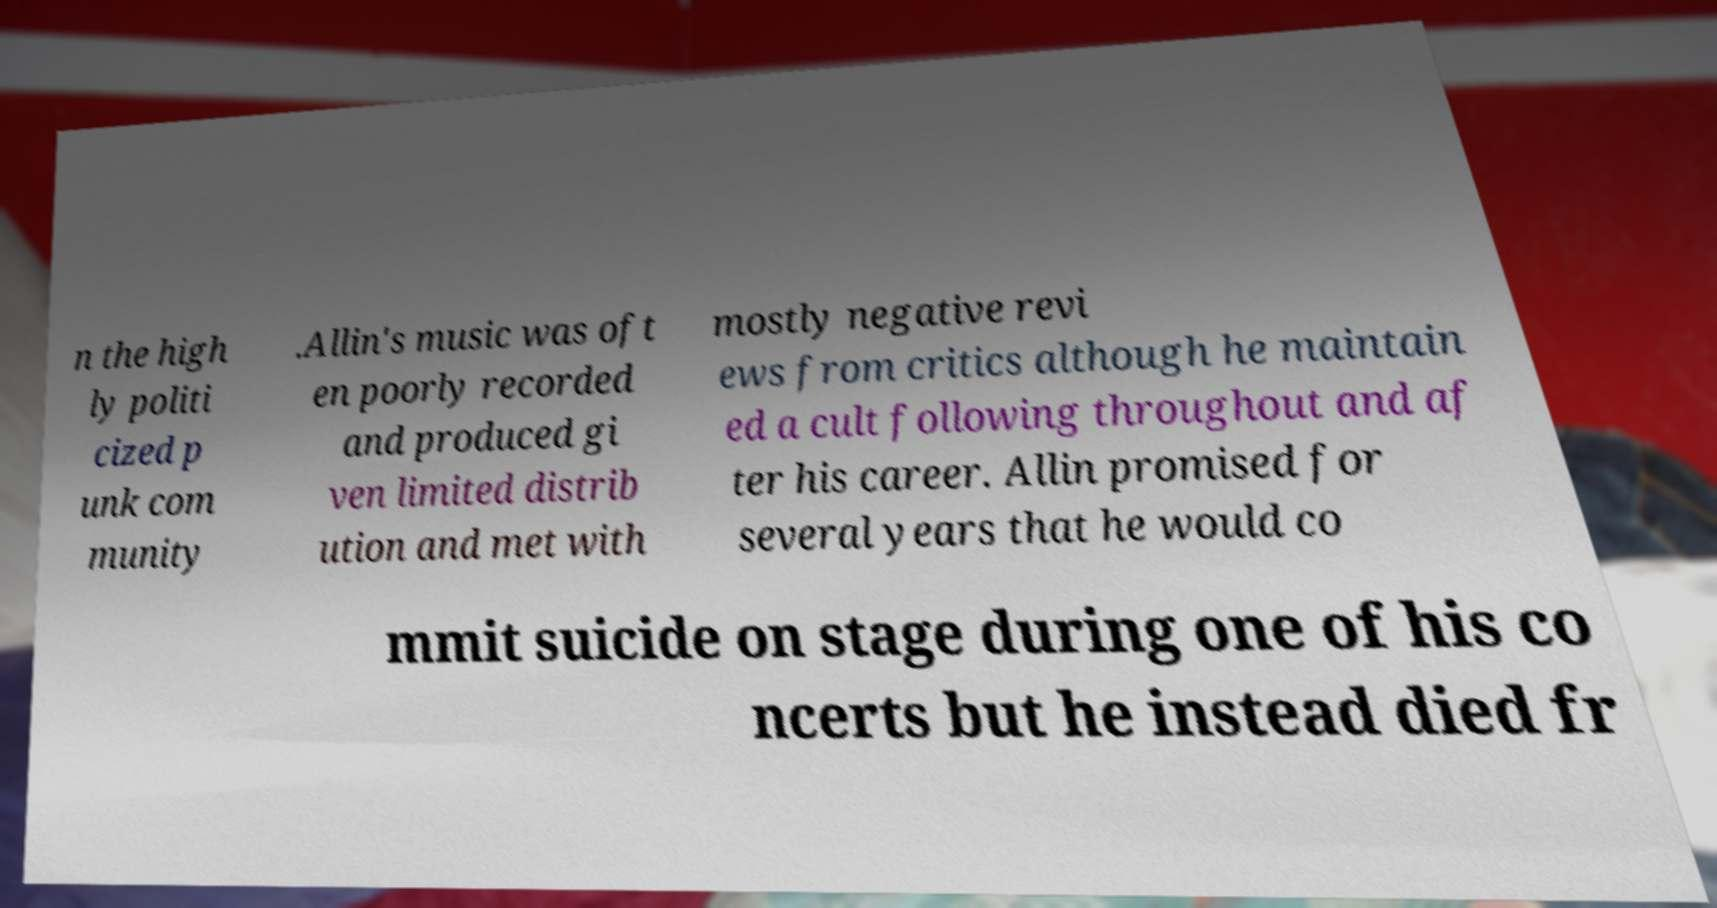Can you accurately transcribe the text from the provided image for me? n the high ly politi cized p unk com munity .Allin's music was oft en poorly recorded and produced gi ven limited distrib ution and met with mostly negative revi ews from critics although he maintain ed a cult following throughout and af ter his career. Allin promised for several years that he would co mmit suicide on stage during one of his co ncerts but he instead died fr 